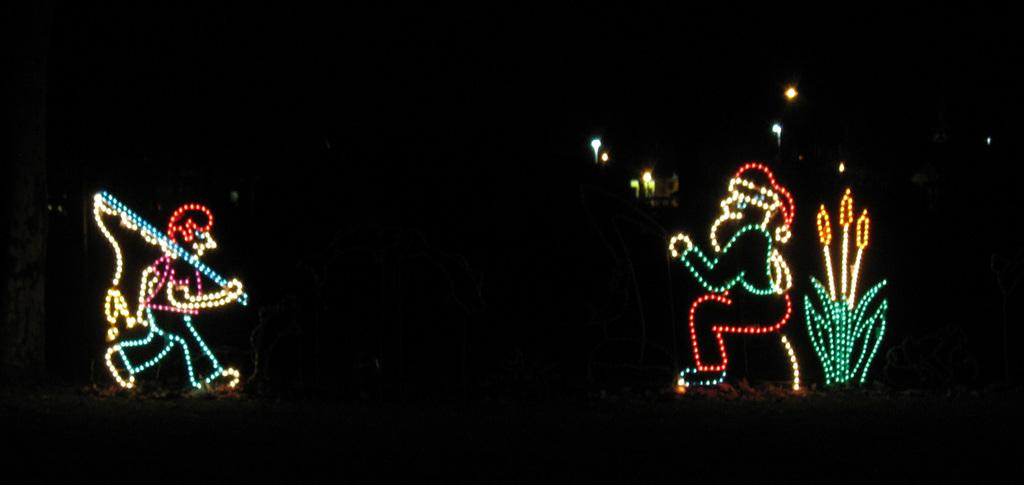How many people are in the image? There are two people depicted in the image. What are the people made of in the image? The people are made with lights. What colors are the lights in the image? The lights are in multicolor. What is the color of the background in the image? The background of the image is dark. Can you see any bears or dogs in the image? No, there are no bears or dogs present in the image. Is there a shop visible in the image? No, there is no shop visible in the image. 